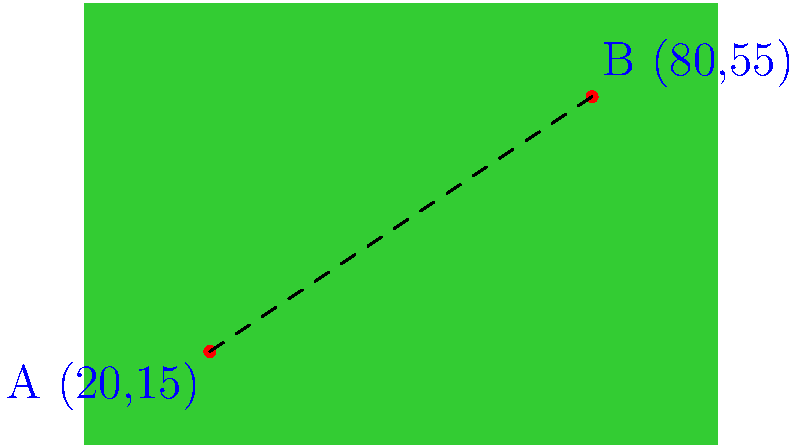On a rugby field, player A is positioned at coordinates (20, 15) and player B is at (80, 55). Using the distance formula, calculate the straight-line distance between these two players. Round your answer to the nearest meter. To find the distance between two points, we use the distance formula:

$$d = \sqrt{(x_2 - x_1)^2 + (y_2 - y_1)^2}$$

Where $(x_1, y_1)$ is the position of player A and $(x_2, y_2)$ is the position of player B.

Step 1: Identify the coordinates
Player A: $(x_1, y_1) = (20, 15)$
Player B: $(x_2, y_2) = (80, 55)$

Step 2: Plug the values into the formula
$$d = \sqrt{(80 - 20)^2 + (55 - 15)^2}$$

Step 3: Simplify inside the parentheses
$$d = \sqrt{(60)^2 + (40)^2}$$

Step 4: Calculate the squares
$$d = \sqrt{3600 + 1600}$$

Step 5: Add inside the square root
$$d = \sqrt{5200}$$

Step 6: Calculate the square root
$$d \approx 72.11 \text{ meters}$$

Step 7: Round to the nearest meter
$$d \approx 72 \text{ meters}$$

Therefore, the distance between player A and player B is approximately 72 meters.
Answer: 72 meters 